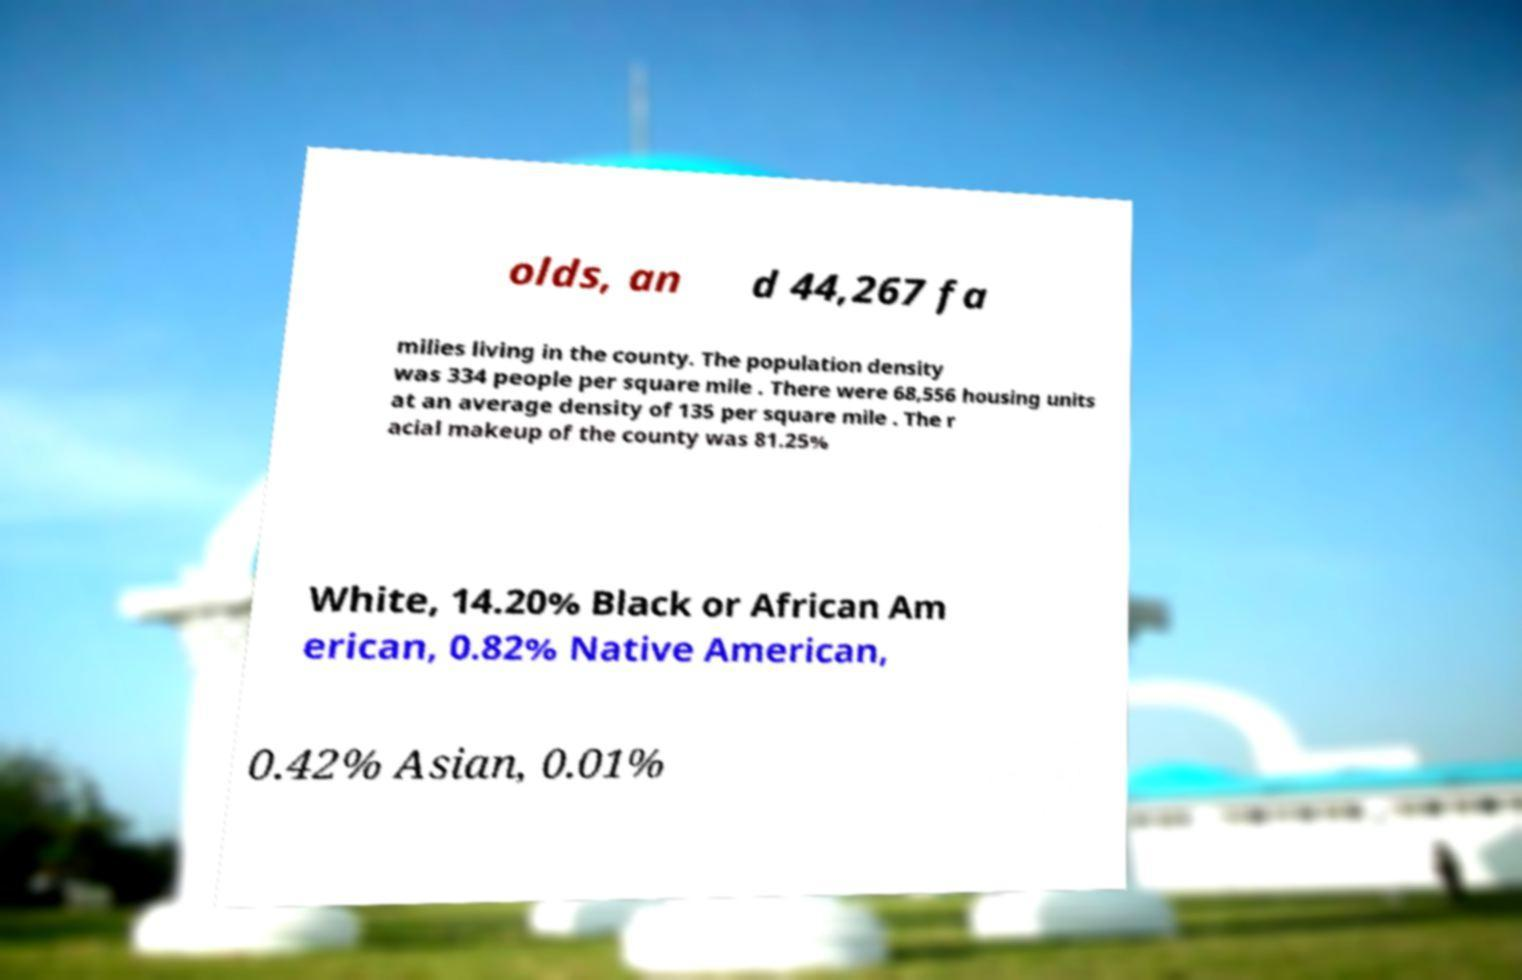There's text embedded in this image that I need extracted. Can you transcribe it verbatim? olds, an d 44,267 fa milies living in the county. The population density was 334 people per square mile . There were 68,556 housing units at an average density of 135 per square mile . The r acial makeup of the county was 81.25% White, 14.20% Black or African Am erican, 0.82% Native American, 0.42% Asian, 0.01% 